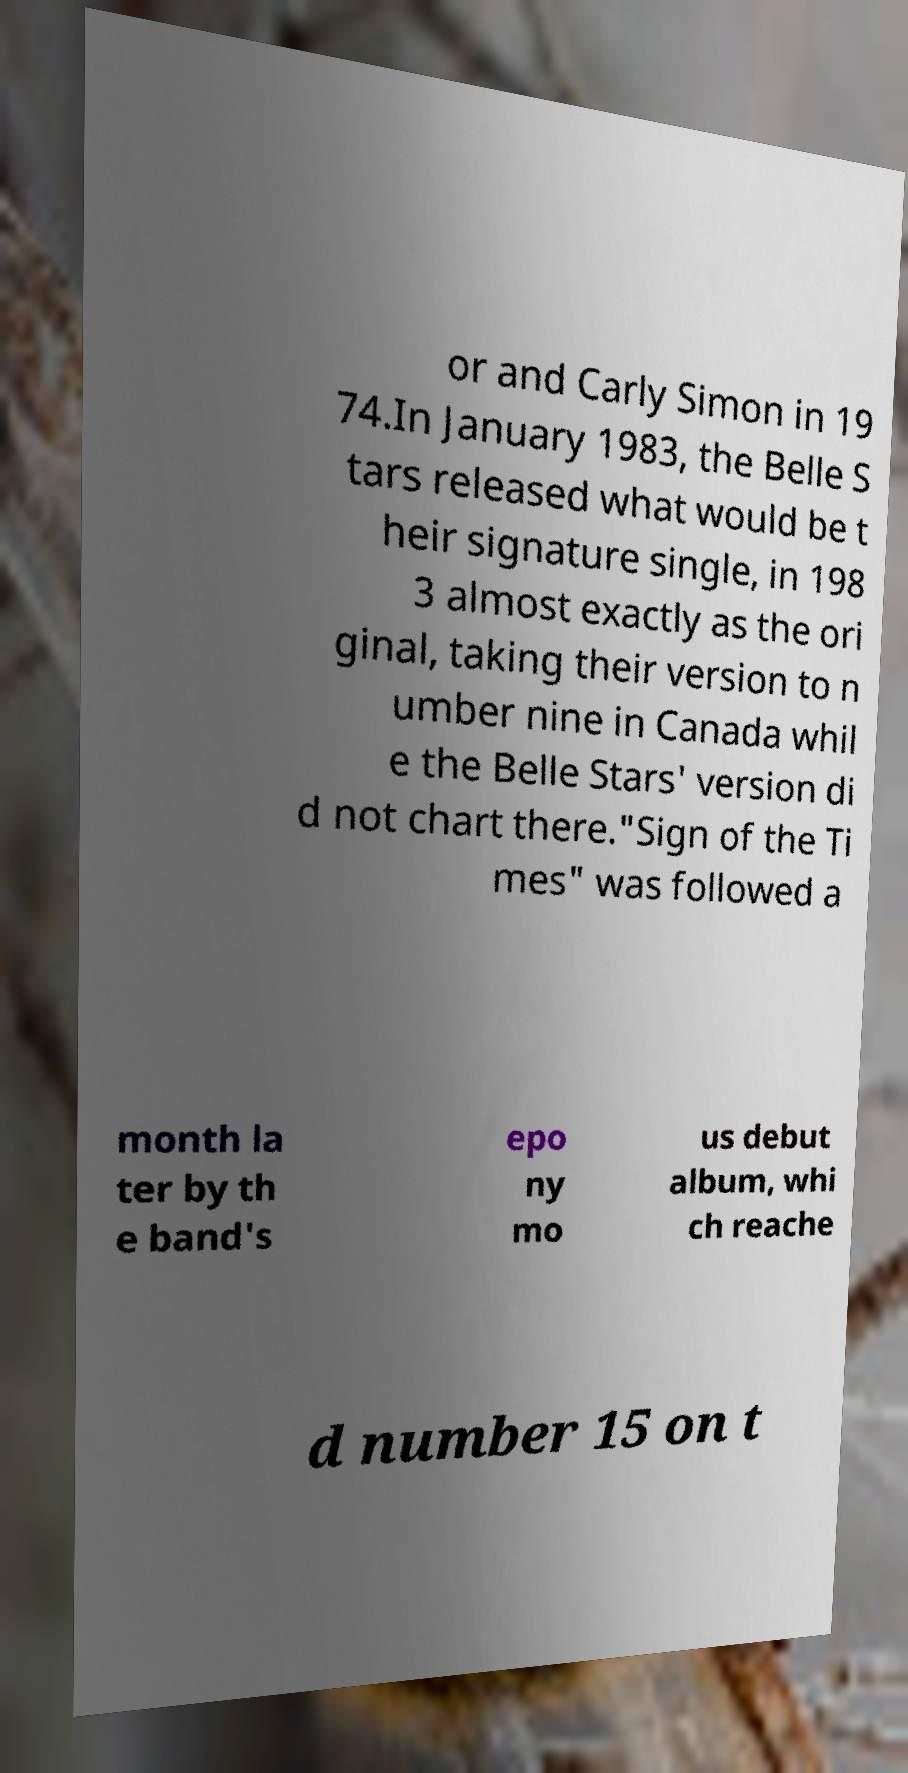What messages or text are displayed in this image? I need them in a readable, typed format. or and Carly Simon in 19 74.In January 1983, the Belle S tars released what would be t heir signature single, in 198 3 almost exactly as the ori ginal, taking their version to n umber nine in Canada whil e the Belle Stars' version di d not chart there."Sign of the Ti mes" was followed a month la ter by th e band's epo ny mo us debut album, whi ch reache d number 15 on t 